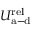<formula> <loc_0><loc_0><loc_500><loc_500>U _ { a - d } ^ { r e l }</formula> 